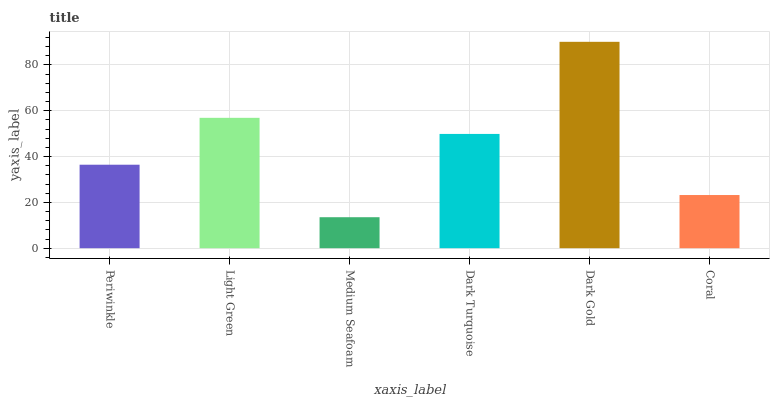Is Medium Seafoam the minimum?
Answer yes or no. Yes. Is Dark Gold the maximum?
Answer yes or no. Yes. Is Light Green the minimum?
Answer yes or no. No. Is Light Green the maximum?
Answer yes or no. No. Is Light Green greater than Periwinkle?
Answer yes or no. Yes. Is Periwinkle less than Light Green?
Answer yes or no. Yes. Is Periwinkle greater than Light Green?
Answer yes or no. No. Is Light Green less than Periwinkle?
Answer yes or no. No. Is Dark Turquoise the high median?
Answer yes or no. Yes. Is Periwinkle the low median?
Answer yes or no. Yes. Is Periwinkle the high median?
Answer yes or no. No. Is Dark Gold the low median?
Answer yes or no. No. 